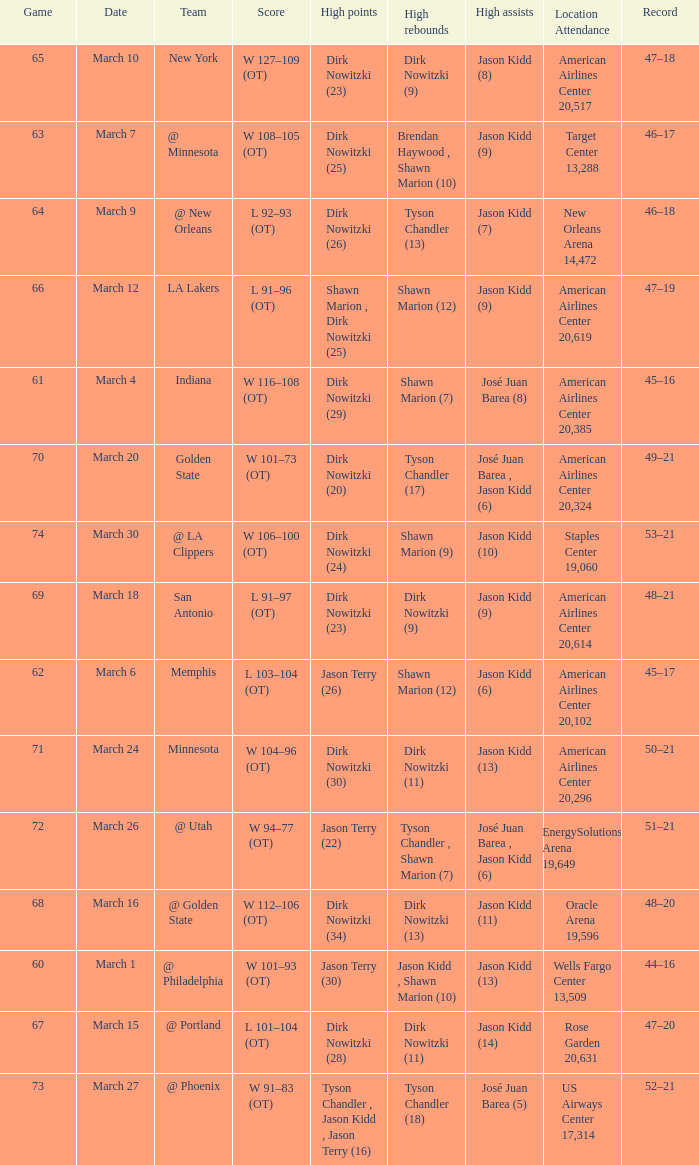Name the high assists for  l 103–104 (ot) Jason Kidd (6). 